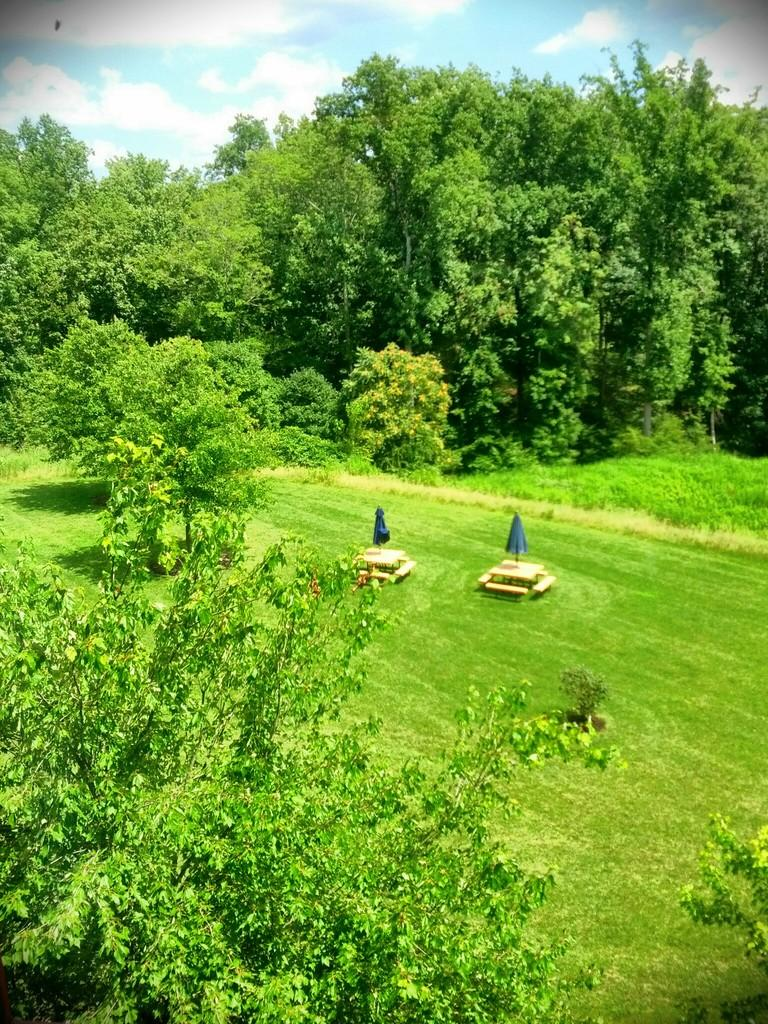What type of vegetation can be seen in the image? There are trees in the image. How are the tables arranged in the image? The tables are arranged on the grass in the image. What can be seen in the sky in the background of the image? The sky is visible in the background of the image. How many roses are on the table in the image? There is no rose present on the table in the image. What level of experience is required to set up the tables in the image? The image does not provide information about the level of experience required to set up the tables. 